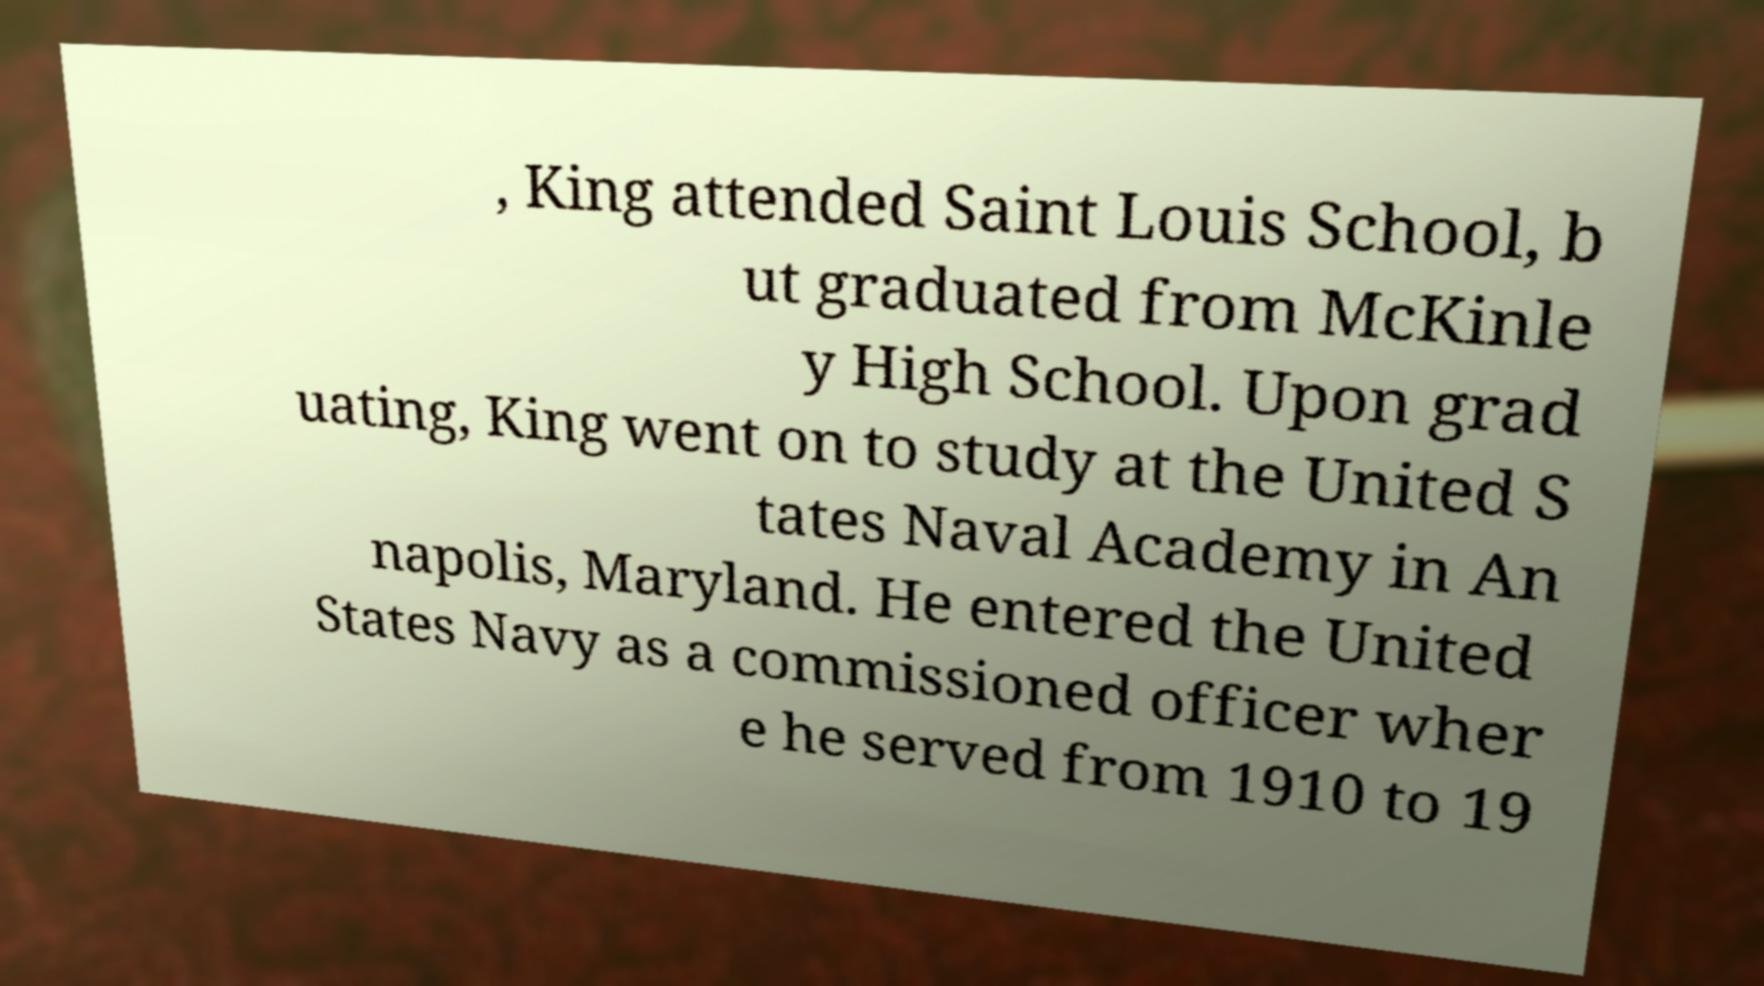Can you accurately transcribe the text from the provided image for me? , King attended Saint Louis School, b ut graduated from McKinle y High School. Upon grad uating, King went on to study at the United S tates Naval Academy in An napolis, Maryland. He entered the United States Navy as a commissioned officer wher e he served from 1910 to 19 